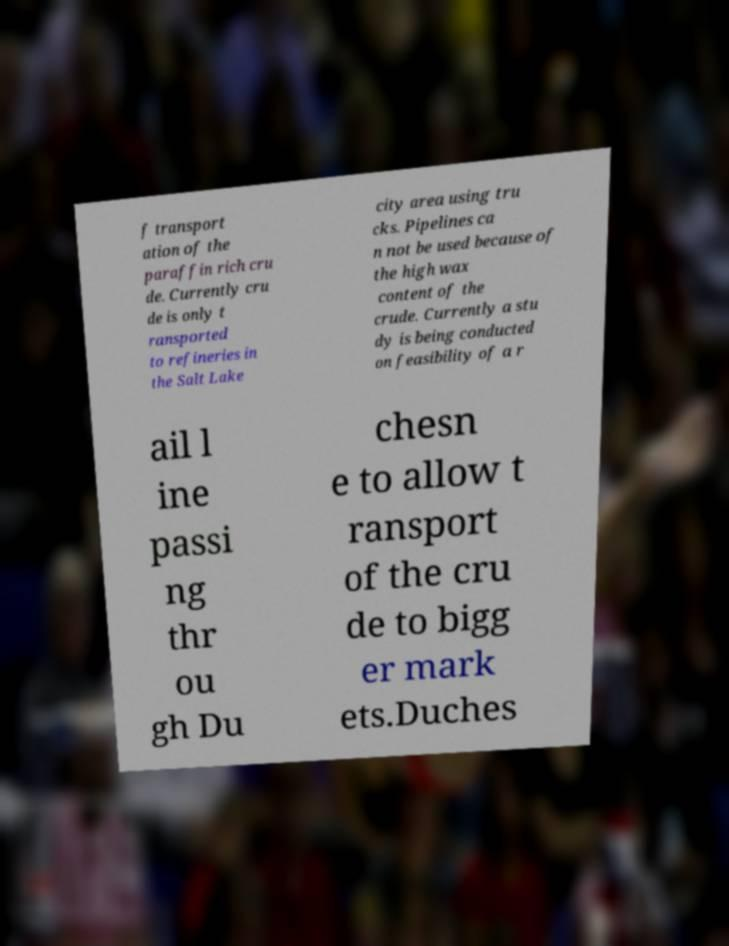I need the written content from this picture converted into text. Can you do that? f transport ation of the paraffin rich cru de. Currently cru de is only t ransported to refineries in the Salt Lake city area using tru cks. Pipelines ca n not be used because of the high wax content of the crude. Currently a stu dy is being conducted on feasibility of a r ail l ine passi ng thr ou gh Du chesn e to allow t ransport of the cru de to bigg er mark ets.Duches 